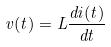Convert formula to latex. <formula><loc_0><loc_0><loc_500><loc_500>v ( t ) = L \frac { d i ( t ) } { d t }</formula> 